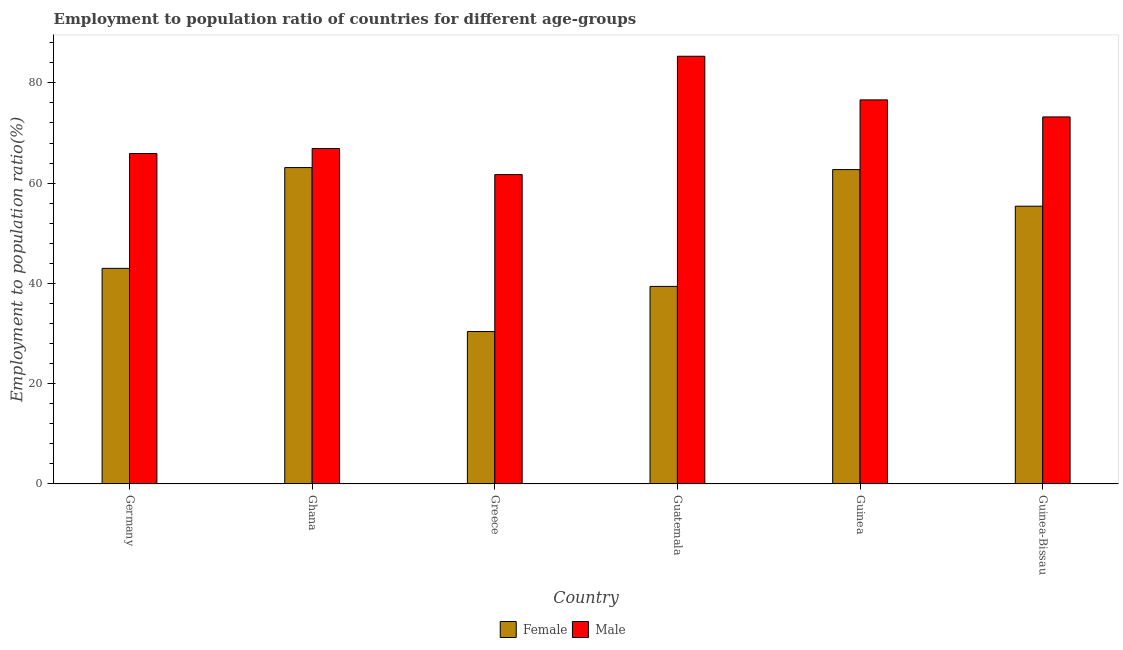Are the number of bars per tick equal to the number of legend labels?
Make the answer very short. Yes. Are the number of bars on each tick of the X-axis equal?
Provide a short and direct response. Yes. How many bars are there on the 4th tick from the right?
Provide a short and direct response. 2. What is the label of the 5th group of bars from the left?
Your answer should be very brief. Guinea. In how many cases, is the number of bars for a given country not equal to the number of legend labels?
Provide a short and direct response. 0. What is the employment to population ratio(female) in Guinea-Bissau?
Provide a succinct answer. 55.4. Across all countries, what is the maximum employment to population ratio(female)?
Your answer should be very brief. 63.1. Across all countries, what is the minimum employment to population ratio(female)?
Make the answer very short. 30.4. In which country was the employment to population ratio(male) maximum?
Offer a very short reply. Guatemala. What is the total employment to population ratio(male) in the graph?
Offer a terse response. 429.6. What is the difference between the employment to population ratio(female) in Guatemala and that in Guinea?
Offer a very short reply. -23.3. What is the difference between the employment to population ratio(male) in Guinea-Bissau and the employment to population ratio(female) in Germany?
Ensure brevity in your answer.  30.2. What is the average employment to population ratio(male) per country?
Your response must be concise. 71.6. What is the difference between the employment to population ratio(male) and employment to population ratio(female) in Greece?
Give a very brief answer. 31.3. In how many countries, is the employment to population ratio(male) greater than 44 %?
Your response must be concise. 6. What is the ratio of the employment to population ratio(male) in Guinea to that in Guinea-Bissau?
Your answer should be compact. 1.05. What is the difference between the highest and the second highest employment to population ratio(male)?
Ensure brevity in your answer.  8.7. What is the difference between the highest and the lowest employment to population ratio(female)?
Your answer should be compact. 32.7. Is the sum of the employment to population ratio(female) in Guinea and Guinea-Bissau greater than the maximum employment to population ratio(male) across all countries?
Offer a terse response. Yes. What does the 2nd bar from the left in Ghana represents?
Ensure brevity in your answer.  Male. What does the 1st bar from the right in Germany represents?
Offer a very short reply. Male. How many bars are there?
Provide a succinct answer. 12. Does the graph contain any zero values?
Give a very brief answer. No. Where does the legend appear in the graph?
Provide a short and direct response. Bottom center. How are the legend labels stacked?
Your response must be concise. Horizontal. What is the title of the graph?
Provide a succinct answer. Employment to population ratio of countries for different age-groups. What is the Employment to population ratio(%) in Male in Germany?
Your response must be concise. 65.9. What is the Employment to population ratio(%) of Female in Ghana?
Your answer should be compact. 63.1. What is the Employment to population ratio(%) in Male in Ghana?
Offer a terse response. 66.9. What is the Employment to population ratio(%) in Female in Greece?
Your answer should be compact. 30.4. What is the Employment to population ratio(%) of Male in Greece?
Ensure brevity in your answer.  61.7. What is the Employment to population ratio(%) in Female in Guatemala?
Ensure brevity in your answer.  39.4. What is the Employment to population ratio(%) in Male in Guatemala?
Make the answer very short. 85.3. What is the Employment to population ratio(%) of Female in Guinea?
Offer a terse response. 62.7. What is the Employment to population ratio(%) of Male in Guinea?
Keep it short and to the point. 76.6. What is the Employment to population ratio(%) of Female in Guinea-Bissau?
Offer a very short reply. 55.4. What is the Employment to population ratio(%) in Male in Guinea-Bissau?
Provide a short and direct response. 73.2. Across all countries, what is the maximum Employment to population ratio(%) in Female?
Ensure brevity in your answer.  63.1. Across all countries, what is the maximum Employment to population ratio(%) in Male?
Give a very brief answer. 85.3. Across all countries, what is the minimum Employment to population ratio(%) of Female?
Ensure brevity in your answer.  30.4. Across all countries, what is the minimum Employment to population ratio(%) in Male?
Your answer should be very brief. 61.7. What is the total Employment to population ratio(%) of Female in the graph?
Give a very brief answer. 294. What is the total Employment to population ratio(%) of Male in the graph?
Offer a very short reply. 429.6. What is the difference between the Employment to population ratio(%) in Female in Germany and that in Ghana?
Make the answer very short. -20.1. What is the difference between the Employment to population ratio(%) of Male in Germany and that in Ghana?
Ensure brevity in your answer.  -1. What is the difference between the Employment to population ratio(%) of Male in Germany and that in Guatemala?
Your response must be concise. -19.4. What is the difference between the Employment to population ratio(%) of Female in Germany and that in Guinea?
Provide a succinct answer. -19.7. What is the difference between the Employment to population ratio(%) of Female in Ghana and that in Greece?
Your answer should be compact. 32.7. What is the difference between the Employment to population ratio(%) in Female in Ghana and that in Guatemala?
Offer a terse response. 23.7. What is the difference between the Employment to population ratio(%) in Male in Ghana and that in Guatemala?
Give a very brief answer. -18.4. What is the difference between the Employment to population ratio(%) in Male in Ghana and that in Guinea?
Ensure brevity in your answer.  -9.7. What is the difference between the Employment to population ratio(%) in Male in Ghana and that in Guinea-Bissau?
Your answer should be very brief. -6.3. What is the difference between the Employment to population ratio(%) of Male in Greece and that in Guatemala?
Provide a short and direct response. -23.6. What is the difference between the Employment to population ratio(%) in Female in Greece and that in Guinea?
Ensure brevity in your answer.  -32.3. What is the difference between the Employment to population ratio(%) in Male in Greece and that in Guinea?
Your answer should be very brief. -14.9. What is the difference between the Employment to population ratio(%) in Male in Greece and that in Guinea-Bissau?
Offer a terse response. -11.5. What is the difference between the Employment to population ratio(%) of Female in Guatemala and that in Guinea?
Offer a very short reply. -23.3. What is the difference between the Employment to population ratio(%) in Male in Guatemala and that in Guinea?
Offer a very short reply. 8.7. What is the difference between the Employment to population ratio(%) in Female in Guatemala and that in Guinea-Bissau?
Keep it short and to the point. -16. What is the difference between the Employment to population ratio(%) in Male in Guatemala and that in Guinea-Bissau?
Give a very brief answer. 12.1. What is the difference between the Employment to population ratio(%) of Female in Guinea and that in Guinea-Bissau?
Ensure brevity in your answer.  7.3. What is the difference between the Employment to population ratio(%) of Male in Guinea and that in Guinea-Bissau?
Your answer should be compact. 3.4. What is the difference between the Employment to population ratio(%) in Female in Germany and the Employment to population ratio(%) in Male in Ghana?
Provide a short and direct response. -23.9. What is the difference between the Employment to population ratio(%) of Female in Germany and the Employment to population ratio(%) of Male in Greece?
Offer a very short reply. -18.7. What is the difference between the Employment to population ratio(%) of Female in Germany and the Employment to population ratio(%) of Male in Guatemala?
Offer a very short reply. -42.3. What is the difference between the Employment to population ratio(%) in Female in Germany and the Employment to population ratio(%) in Male in Guinea?
Offer a terse response. -33.6. What is the difference between the Employment to population ratio(%) in Female in Germany and the Employment to population ratio(%) in Male in Guinea-Bissau?
Offer a very short reply. -30.2. What is the difference between the Employment to population ratio(%) of Female in Ghana and the Employment to population ratio(%) of Male in Greece?
Make the answer very short. 1.4. What is the difference between the Employment to population ratio(%) in Female in Ghana and the Employment to population ratio(%) in Male in Guatemala?
Ensure brevity in your answer.  -22.2. What is the difference between the Employment to population ratio(%) of Female in Ghana and the Employment to population ratio(%) of Male in Guinea-Bissau?
Give a very brief answer. -10.1. What is the difference between the Employment to population ratio(%) of Female in Greece and the Employment to population ratio(%) of Male in Guatemala?
Keep it short and to the point. -54.9. What is the difference between the Employment to population ratio(%) of Female in Greece and the Employment to population ratio(%) of Male in Guinea?
Provide a short and direct response. -46.2. What is the difference between the Employment to population ratio(%) in Female in Greece and the Employment to population ratio(%) in Male in Guinea-Bissau?
Make the answer very short. -42.8. What is the difference between the Employment to population ratio(%) of Female in Guatemala and the Employment to population ratio(%) of Male in Guinea?
Ensure brevity in your answer.  -37.2. What is the difference between the Employment to population ratio(%) of Female in Guatemala and the Employment to population ratio(%) of Male in Guinea-Bissau?
Offer a very short reply. -33.8. What is the difference between the Employment to population ratio(%) in Female in Guinea and the Employment to population ratio(%) in Male in Guinea-Bissau?
Keep it short and to the point. -10.5. What is the average Employment to population ratio(%) of Male per country?
Your answer should be compact. 71.6. What is the difference between the Employment to population ratio(%) of Female and Employment to population ratio(%) of Male in Germany?
Offer a very short reply. -22.9. What is the difference between the Employment to population ratio(%) of Female and Employment to population ratio(%) of Male in Ghana?
Ensure brevity in your answer.  -3.8. What is the difference between the Employment to population ratio(%) of Female and Employment to population ratio(%) of Male in Greece?
Your answer should be very brief. -31.3. What is the difference between the Employment to population ratio(%) in Female and Employment to population ratio(%) in Male in Guatemala?
Make the answer very short. -45.9. What is the difference between the Employment to population ratio(%) of Female and Employment to population ratio(%) of Male in Guinea-Bissau?
Your answer should be very brief. -17.8. What is the ratio of the Employment to population ratio(%) in Female in Germany to that in Ghana?
Offer a very short reply. 0.68. What is the ratio of the Employment to population ratio(%) in Male in Germany to that in Ghana?
Your answer should be compact. 0.99. What is the ratio of the Employment to population ratio(%) of Female in Germany to that in Greece?
Give a very brief answer. 1.41. What is the ratio of the Employment to population ratio(%) of Male in Germany to that in Greece?
Keep it short and to the point. 1.07. What is the ratio of the Employment to population ratio(%) of Female in Germany to that in Guatemala?
Provide a succinct answer. 1.09. What is the ratio of the Employment to population ratio(%) in Male in Germany to that in Guatemala?
Your answer should be very brief. 0.77. What is the ratio of the Employment to population ratio(%) of Female in Germany to that in Guinea?
Ensure brevity in your answer.  0.69. What is the ratio of the Employment to population ratio(%) in Male in Germany to that in Guinea?
Ensure brevity in your answer.  0.86. What is the ratio of the Employment to population ratio(%) in Female in Germany to that in Guinea-Bissau?
Your answer should be very brief. 0.78. What is the ratio of the Employment to population ratio(%) in Male in Germany to that in Guinea-Bissau?
Your response must be concise. 0.9. What is the ratio of the Employment to population ratio(%) in Female in Ghana to that in Greece?
Your response must be concise. 2.08. What is the ratio of the Employment to population ratio(%) in Male in Ghana to that in Greece?
Provide a short and direct response. 1.08. What is the ratio of the Employment to population ratio(%) in Female in Ghana to that in Guatemala?
Provide a short and direct response. 1.6. What is the ratio of the Employment to population ratio(%) in Male in Ghana to that in Guatemala?
Make the answer very short. 0.78. What is the ratio of the Employment to population ratio(%) of Female in Ghana to that in Guinea?
Ensure brevity in your answer.  1.01. What is the ratio of the Employment to population ratio(%) in Male in Ghana to that in Guinea?
Provide a short and direct response. 0.87. What is the ratio of the Employment to population ratio(%) of Female in Ghana to that in Guinea-Bissau?
Your answer should be very brief. 1.14. What is the ratio of the Employment to population ratio(%) of Male in Ghana to that in Guinea-Bissau?
Give a very brief answer. 0.91. What is the ratio of the Employment to population ratio(%) in Female in Greece to that in Guatemala?
Keep it short and to the point. 0.77. What is the ratio of the Employment to population ratio(%) in Male in Greece to that in Guatemala?
Give a very brief answer. 0.72. What is the ratio of the Employment to population ratio(%) of Female in Greece to that in Guinea?
Provide a succinct answer. 0.48. What is the ratio of the Employment to population ratio(%) in Male in Greece to that in Guinea?
Provide a succinct answer. 0.81. What is the ratio of the Employment to population ratio(%) in Female in Greece to that in Guinea-Bissau?
Ensure brevity in your answer.  0.55. What is the ratio of the Employment to population ratio(%) of Male in Greece to that in Guinea-Bissau?
Your answer should be very brief. 0.84. What is the ratio of the Employment to population ratio(%) in Female in Guatemala to that in Guinea?
Provide a succinct answer. 0.63. What is the ratio of the Employment to population ratio(%) in Male in Guatemala to that in Guinea?
Keep it short and to the point. 1.11. What is the ratio of the Employment to population ratio(%) in Female in Guatemala to that in Guinea-Bissau?
Offer a terse response. 0.71. What is the ratio of the Employment to population ratio(%) of Male in Guatemala to that in Guinea-Bissau?
Keep it short and to the point. 1.17. What is the ratio of the Employment to population ratio(%) of Female in Guinea to that in Guinea-Bissau?
Keep it short and to the point. 1.13. What is the ratio of the Employment to population ratio(%) of Male in Guinea to that in Guinea-Bissau?
Offer a very short reply. 1.05. What is the difference between the highest and the second highest Employment to population ratio(%) of Male?
Ensure brevity in your answer.  8.7. What is the difference between the highest and the lowest Employment to population ratio(%) in Female?
Keep it short and to the point. 32.7. What is the difference between the highest and the lowest Employment to population ratio(%) of Male?
Offer a very short reply. 23.6. 